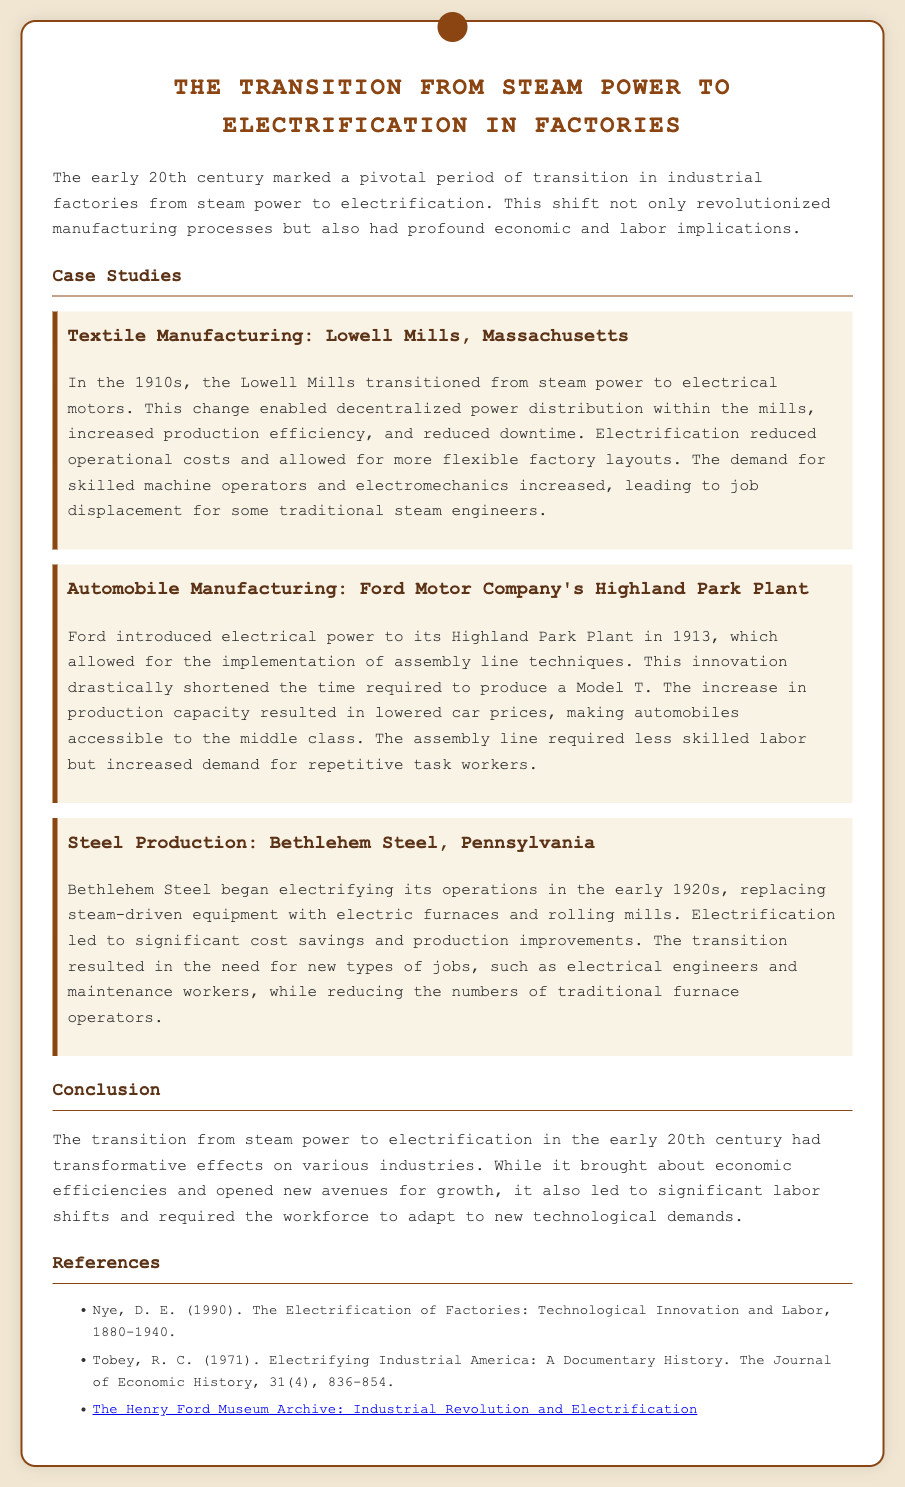What was the main focus of the ticket? The ticket focuses on the transition from steam power to electrification in factories, specifically during the early 20th century.
Answer: Transition from steam power to electrification in factories Which industry is associated with the Lowell Mills case study? The Lowell Mills case study specifically addresses the textile manufacturing industry.
Answer: Textile Manufacturing In what year did Ford introduce electrical power to its Highland Park Plant? Ford introduced electrical power in the year 1913.
Answer: 1913 What was a direct result of the electrification at Bethlehem Steel? The electrification at Bethlehem Steel led to significant cost savings and production improvements.
Answer: Cost savings and production improvements What type of job demand increased due to the shift to electrification in textile manufacturing? The demand for skilled machine operators and electromechanics increased due to electrification.
Answer: Skilled machine operators and electromechanics What innovative technique did Ford implement with electrical power in 1913? Ford implemented assembly line techniques with the introduction of electrical power.
Answer: Assembly line techniques Which document is referenced regarding the Electrification of Factories? The referenced document is "The Electrification of Factories: Technological Innovation and Labor, 1880-1940" by D. E. Nye.
Answer: The Electrification of Factories: Technological Innovation and Labor, 1880-1940 How did the transition to electric power affect labor in the Ford plant? The assembly line required less skilled labor but increased demand for repetitive task workers.
Answer: Less skilled labor and increased demand for repetitive task workers What was the consequence of electrification for traditional furnace operators at Bethlehem Steel? The transition to electrification reduced the number of traditional furnace operators.
Answer: Reduced numbers of traditional furnace operators 